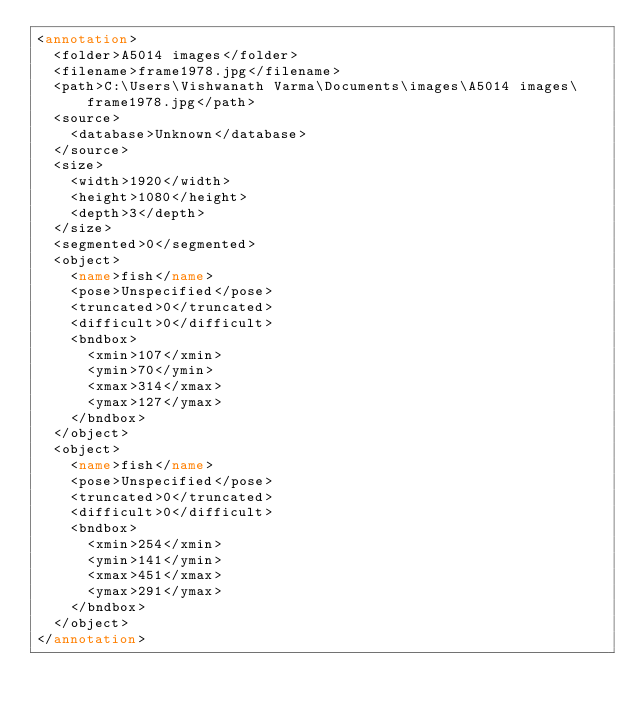<code> <loc_0><loc_0><loc_500><loc_500><_XML_><annotation>
	<folder>A5014 images</folder>
	<filename>frame1978.jpg</filename>
	<path>C:\Users\Vishwanath Varma\Documents\images\A5014 images\frame1978.jpg</path>
	<source>
		<database>Unknown</database>
	</source>
	<size>
		<width>1920</width>
		<height>1080</height>
		<depth>3</depth>
	</size>
	<segmented>0</segmented>
	<object>
		<name>fish</name>
		<pose>Unspecified</pose>
		<truncated>0</truncated>
		<difficult>0</difficult>
		<bndbox>
			<xmin>107</xmin>
			<ymin>70</ymin>
			<xmax>314</xmax>
			<ymax>127</ymax>
		</bndbox>
	</object>
	<object>
		<name>fish</name>
		<pose>Unspecified</pose>
		<truncated>0</truncated>
		<difficult>0</difficult>
		<bndbox>
			<xmin>254</xmin>
			<ymin>141</ymin>
			<xmax>451</xmax>
			<ymax>291</ymax>
		</bndbox>
	</object>
</annotation>
</code> 